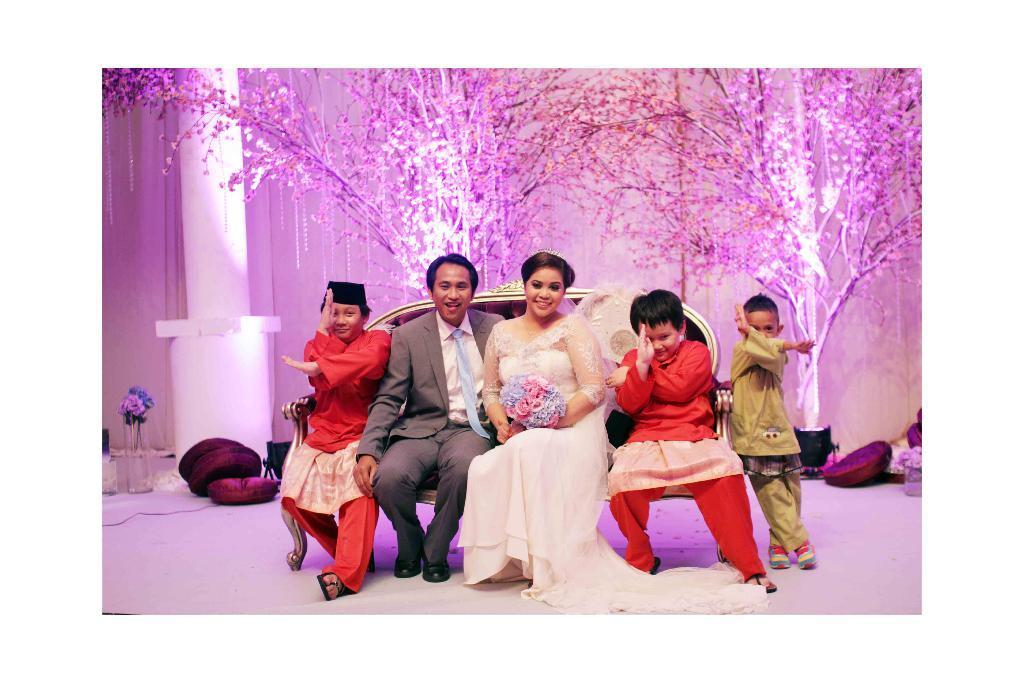Could you give a brief overview of what you see in this image? In the image there are four people sitting on the chair and beside them a kid is standing by leaning towards the chair. In the background there are some decorations and lights with the trees. 